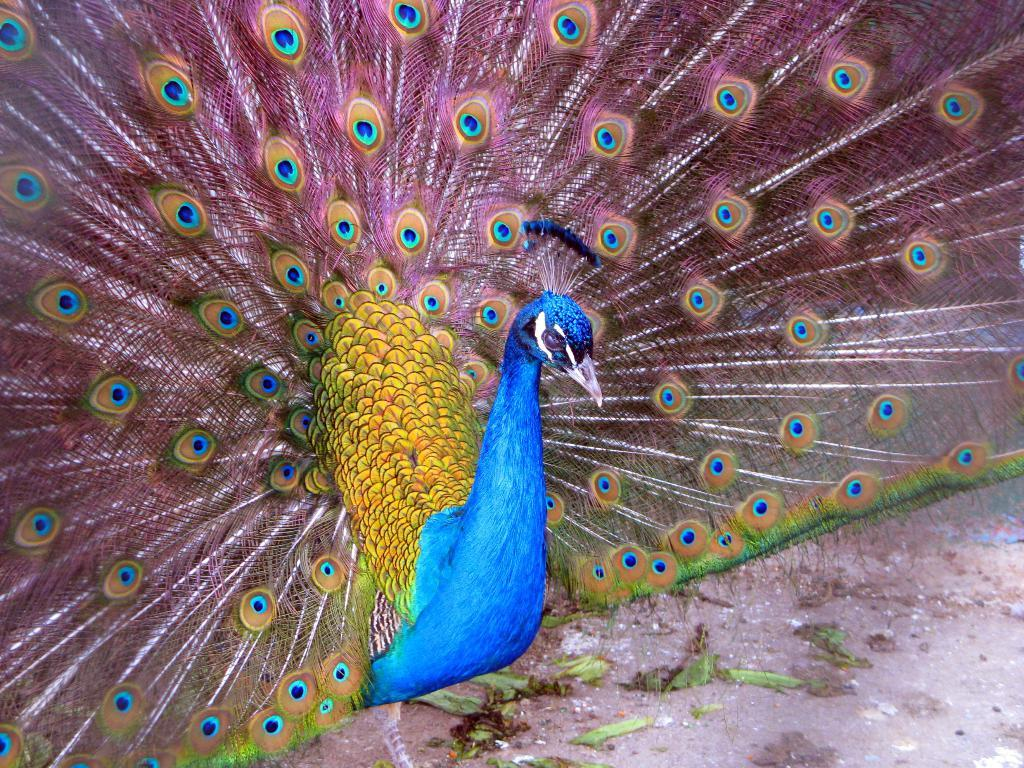What type of bird is in the image? There is a blue peacock in the image. What is the peacock doing in the image? The peacock is opening its feathers in the image. What type of vegetation can be seen in the image? There are leaves and grass visible in the image. What type of ground is present in the image? Soil is present in the image. Can you tell if the image has been altered or edited? The image might be edited, but it's not certain from the provided facts. What shape is the animal jumping in the image? There is no animal jumping in the image, as it features a blue peacock opening its feathers. 